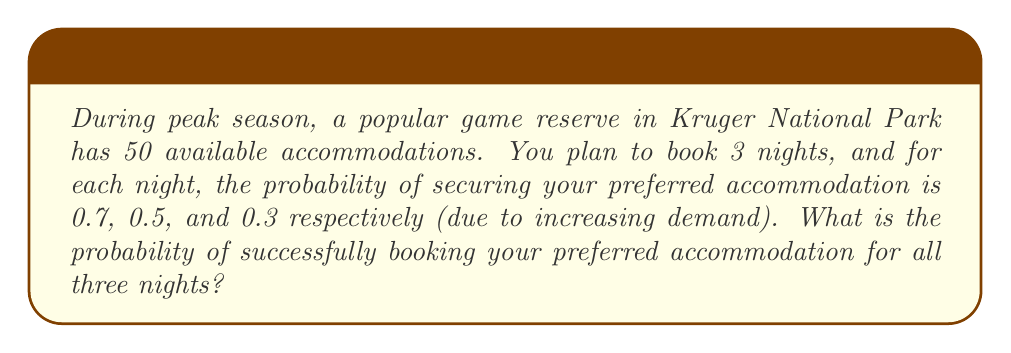Can you solve this math problem? To solve this problem, we need to use the multiplication rule of probability for independent events. Each night's booking is considered an independent event.

Let's define the events:
$A$: Booking preferred accommodation on the first night
$B$: Booking preferred accommodation on the second night
$C$: Booking preferred accommodation on the third night

Given probabilities:
$P(A) = 0.7$
$P(B) = 0.5$
$P(C) = 0.3$

The probability of all three events occurring is:

$$P(A \cap B \cap C) = P(A) \times P(B) \times P(C)$$

Substituting the values:

$$P(A \cap B \cap C) = 0.7 \times 0.5 \times 0.3$$

Calculating:

$$P(A \cap B \cap C) = 0.105$$

Therefore, the probability of successfully booking your preferred accommodation for all three nights is 0.105 or 10.5%.
Answer: 0.105 